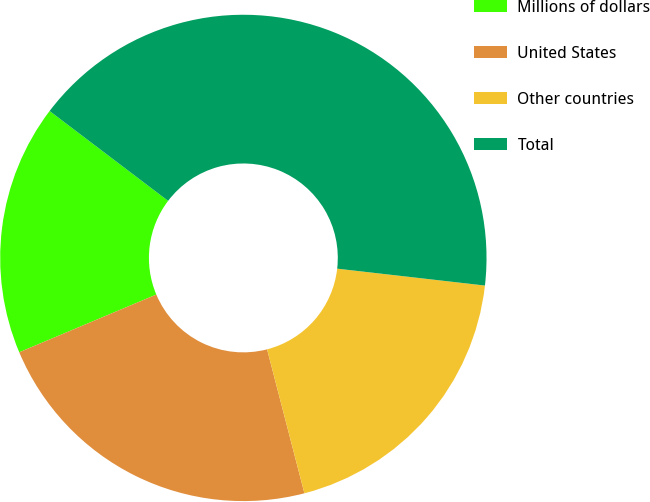<chart> <loc_0><loc_0><loc_500><loc_500><pie_chart><fcel>Millions of dollars<fcel>United States<fcel>Other countries<fcel>Total<nl><fcel>16.67%<fcel>22.7%<fcel>19.15%<fcel>41.49%<nl></chart> 